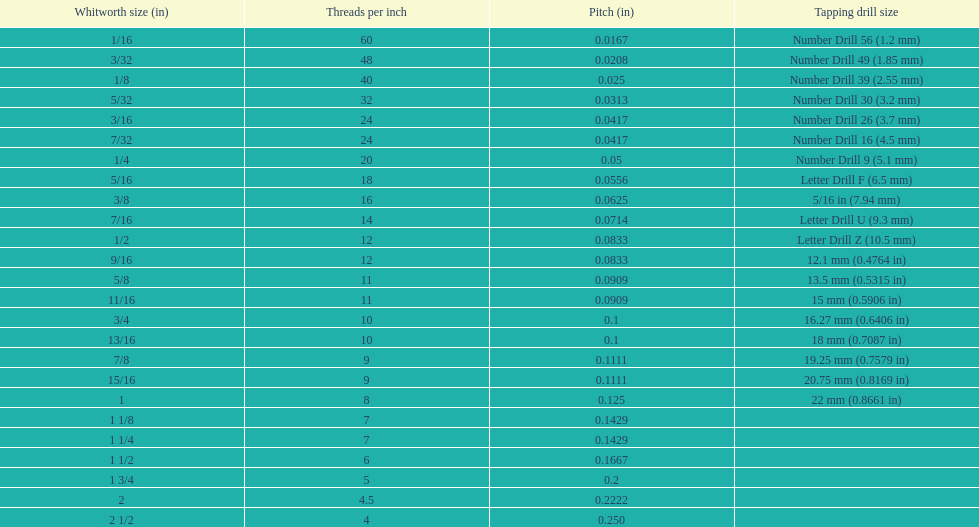Does any whitworth size have the same core diameter as the number drill 26? 3/16. 